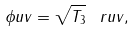<formula> <loc_0><loc_0><loc_500><loc_500>\phi u v = \sqrt { T _ { 3 } } \, \ r u v ,</formula> 